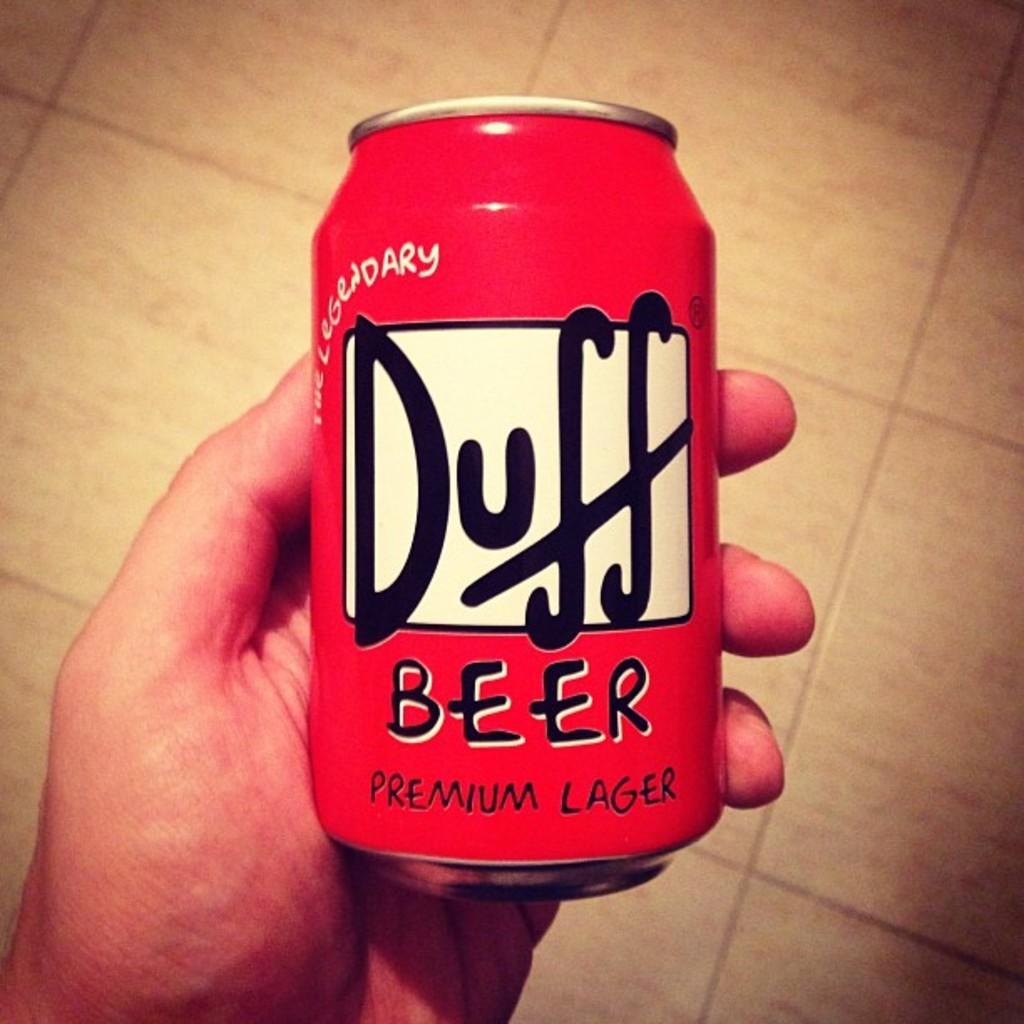Provide a one-sentence caption for the provided image. A hand is holding a red can of Duff beer. 